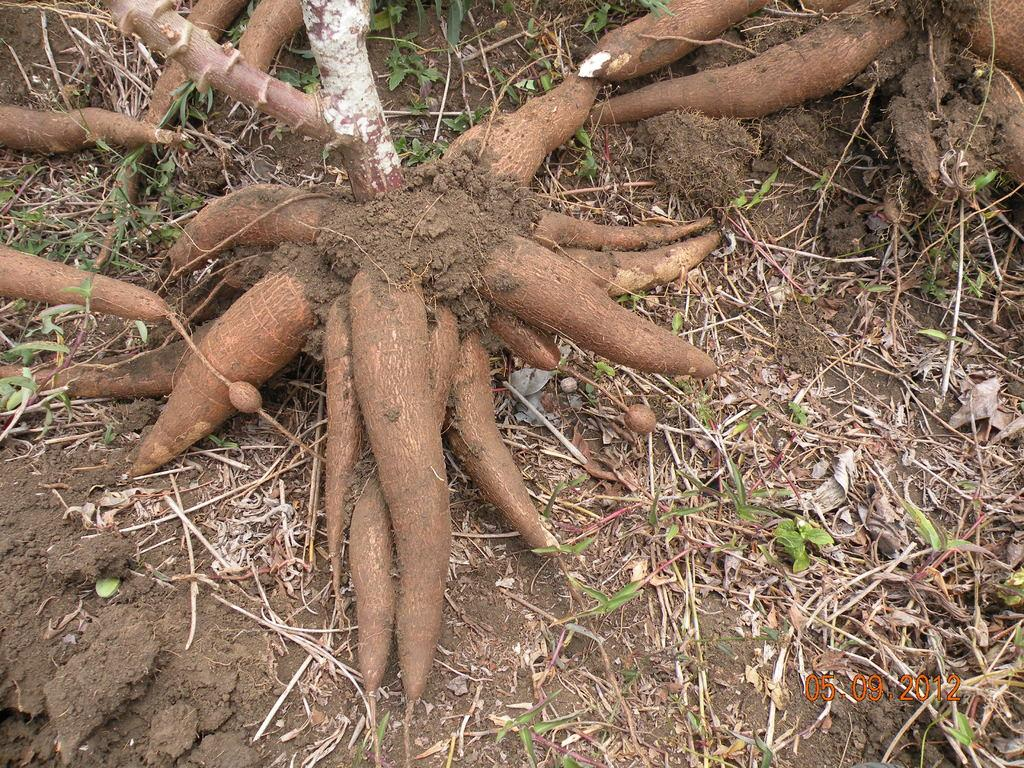What type of plant feature can be seen in the image? There are tree roots in the image. What color are the tree roots? The tree roots are brown in color. What type of vegetation is present on the ground in the image? There is grass on the ground in the image. How many tombstones can be seen in the image? There are no tombstones present in the image; it features tree roots and grass. What type of footwear is visible on the tree roots in the image? There are no feet or footwear visible in the image, as it focuses on tree roots and grass. 